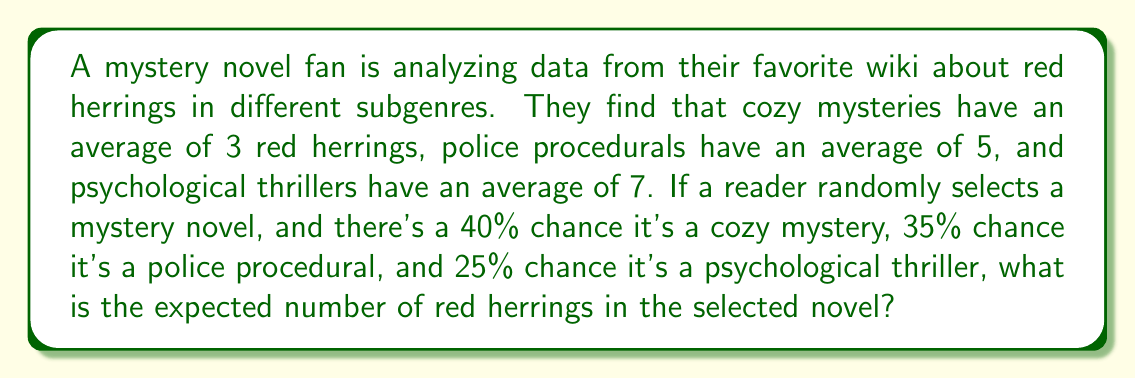Help me with this question. Let's approach this step-by-step using the concept of expected value:

1) Define the random variable X as the number of red herrings in a randomly selected mystery novel.

2) We have three possible outcomes:
   - Cozy mystery (C): P(C) = 0.40, E(X|C) = 3
   - Police procedural (P): P(P) = 0.35, E(X|P) = 5
   - Psychological thriller (T): P(T) = 0.25, E(X|T) = 7

3) The formula for expected value is:
   $$E(X) = \sum_{i} x_i \cdot P(X = x_i)$$

4) In this case, we can calculate:
   $$E(X) = E(X|C) \cdot P(C) + E(X|P) \cdot P(P) + E(X|T) \cdot P(T)$$

5) Substituting the values:
   $$E(X) = 3 \cdot 0.40 + 5 \cdot 0.35 + 7 \cdot 0.25$$

6) Calculate:
   $$E(X) = 1.20 + 1.75 + 1.75 = 4.70$$

Therefore, the expected number of red herrings in a randomly selected mystery novel is 4.70.
Answer: 4.70 